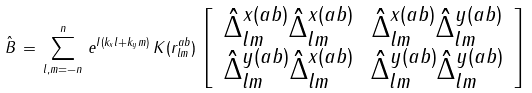<formula> <loc_0><loc_0><loc_500><loc_500>\hat { B } \, = \, \sum _ { l , m = - n } ^ { n } \, e ^ { I ( k _ { x } l + k _ { y } m ) } \, K ( r _ { l m } ^ { a b } ) \, \left [ \, \begin{array} { c c } \hat { \Delta } _ { l m } ^ { x ( a b ) } \hat { \Delta } _ { l m } ^ { x ( a b ) } & \hat { \Delta } _ { l m } ^ { x ( a b ) } \hat { \Delta } _ { l m } ^ { y ( a b ) } \\ \hat { \Delta } _ { l m } ^ { y ( a b ) } \hat { \Delta } _ { l m } ^ { x ( a b ) } & \hat { \Delta } _ { l m } ^ { y ( a b ) } \hat { \Delta } _ { l m } ^ { y ( a b ) } \end{array} \, \right ]</formula> 